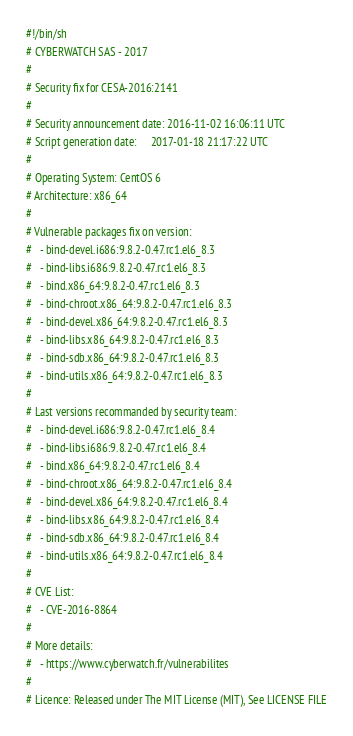<code> <loc_0><loc_0><loc_500><loc_500><_Bash_>#!/bin/sh
# CYBERWATCH SAS - 2017
#
# Security fix for CESA-2016:2141
#
# Security announcement date: 2016-11-02 16:06:11 UTC
# Script generation date:     2017-01-18 21:17:22 UTC
#
# Operating System: CentOS 6
# Architecture: x86_64
#
# Vulnerable packages fix on version:
#   - bind-devel.i686:9.8.2-0.47.rc1.el6_8.3
#   - bind-libs.i686:9.8.2-0.47.rc1.el6_8.3
#   - bind.x86_64:9.8.2-0.47.rc1.el6_8.3
#   - bind-chroot.x86_64:9.8.2-0.47.rc1.el6_8.3
#   - bind-devel.x86_64:9.8.2-0.47.rc1.el6_8.3
#   - bind-libs.x86_64:9.8.2-0.47.rc1.el6_8.3
#   - bind-sdb.x86_64:9.8.2-0.47.rc1.el6_8.3
#   - bind-utils.x86_64:9.8.2-0.47.rc1.el6_8.3
#
# Last versions recommanded by security team:
#   - bind-devel.i686:9.8.2-0.47.rc1.el6_8.4
#   - bind-libs.i686:9.8.2-0.47.rc1.el6_8.4
#   - bind.x86_64:9.8.2-0.47.rc1.el6_8.4
#   - bind-chroot.x86_64:9.8.2-0.47.rc1.el6_8.4
#   - bind-devel.x86_64:9.8.2-0.47.rc1.el6_8.4
#   - bind-libs.x86_64:9.8.2-0.47.rc1.el6_8.4
#   - bind-sdb.x86_64:9.8.2-0.47.rc1.el6_8.4
#   - bind-utils.x86_64:9.8.2-0.47.rc1.el6_8.4
#
# CVE List:
#   - CVE-2016-8864
#
# More details:
#   - https://www.cyberwatch.fr/vulnerabilites
#
# Licence: Released under The MIT License (MIT), See LICENSE FILE</code> 